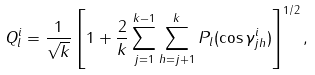<formula> <loc_0><loc_0><loc_500><loc_500>Q _ { l } ^ { i } = \frac { 1 } { \sqrt { k } } \left [ 1 + \frac { 2 } { k } \sum _ { j = 1 } ^ { k - 1 } \sum _ { h = j + 1 } ^ { k } P _ { l } ( \cos \gamma _ { j h } ^ { i } ) \right ] ^ { 1 / 2 } ,</formula> 